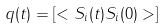Convert formula to latex. <formula><loc_0><loc_0><loc_500><loc_500>q ( t ) = \left [ < S _ { i } ( t ) S _ { i } ( 0 ) > \right ]</formula> 